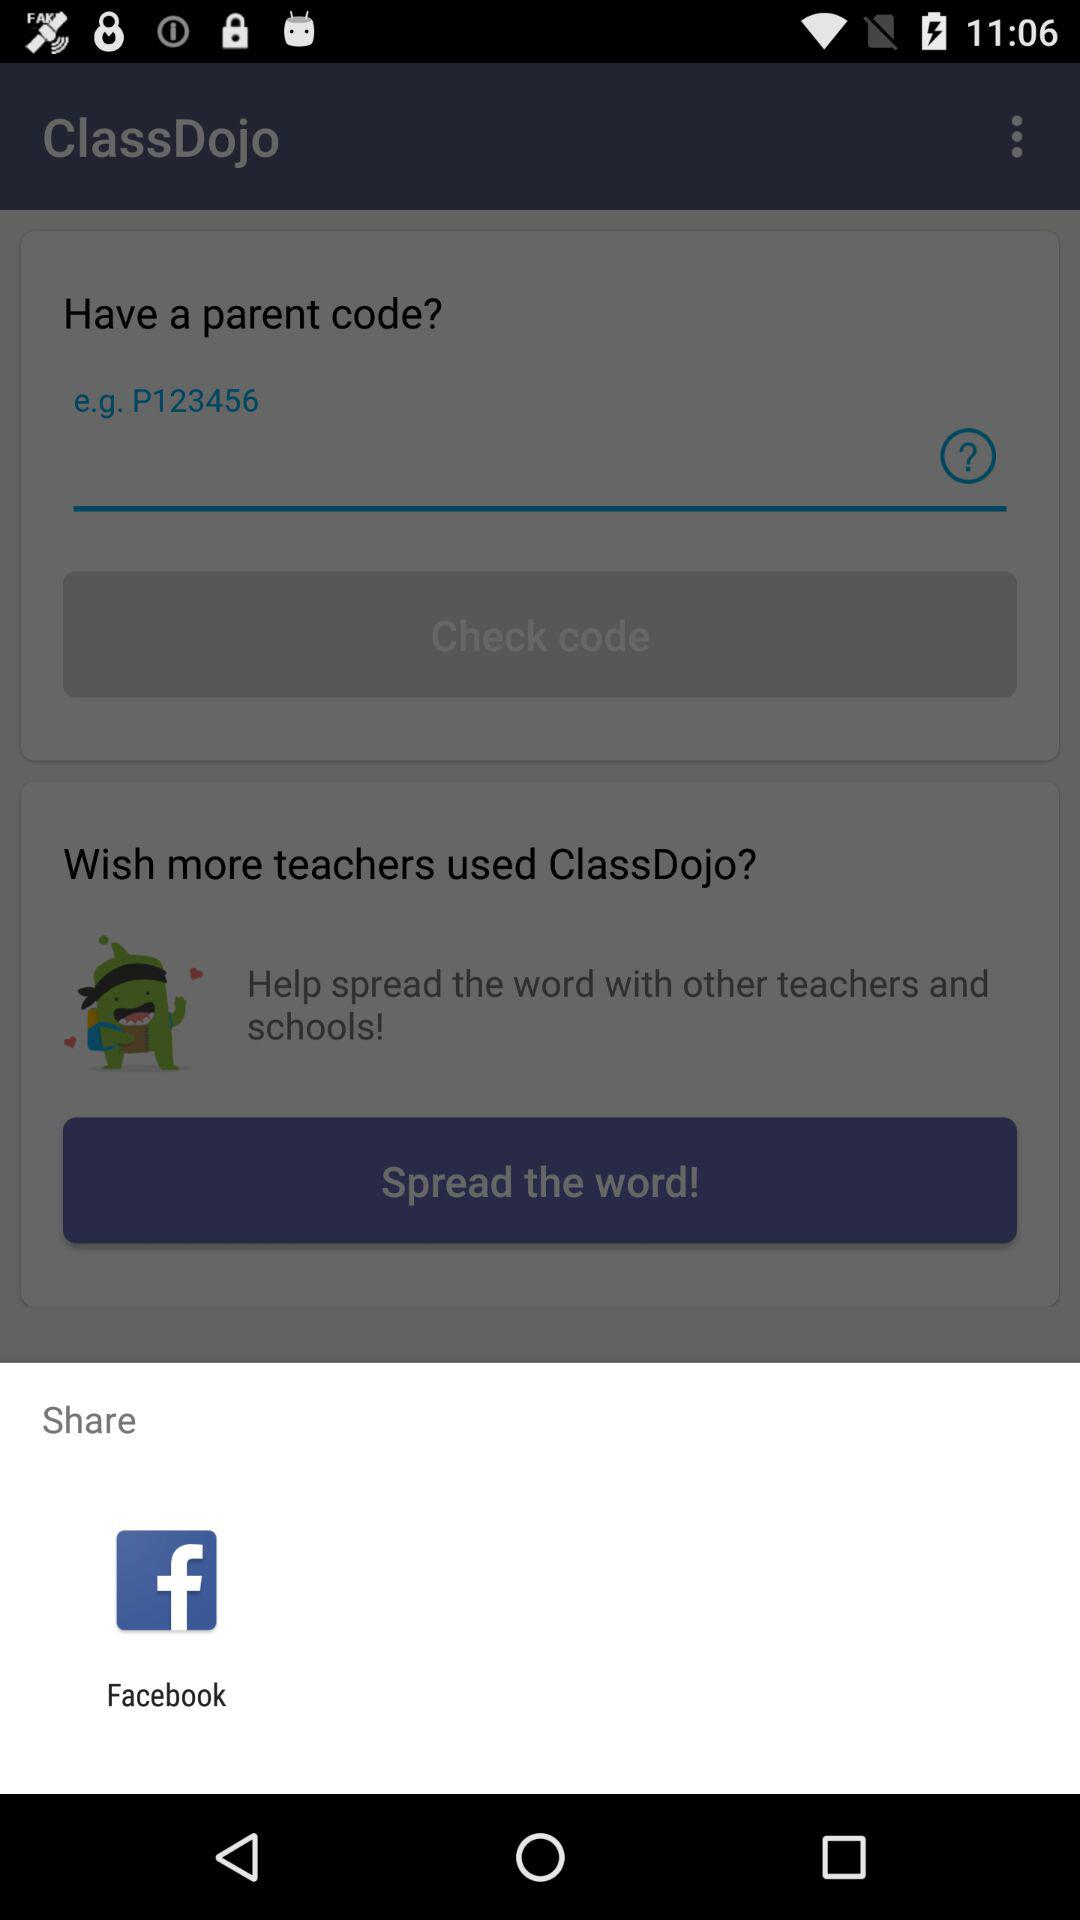What application is used for share? The application is "Facebook". 